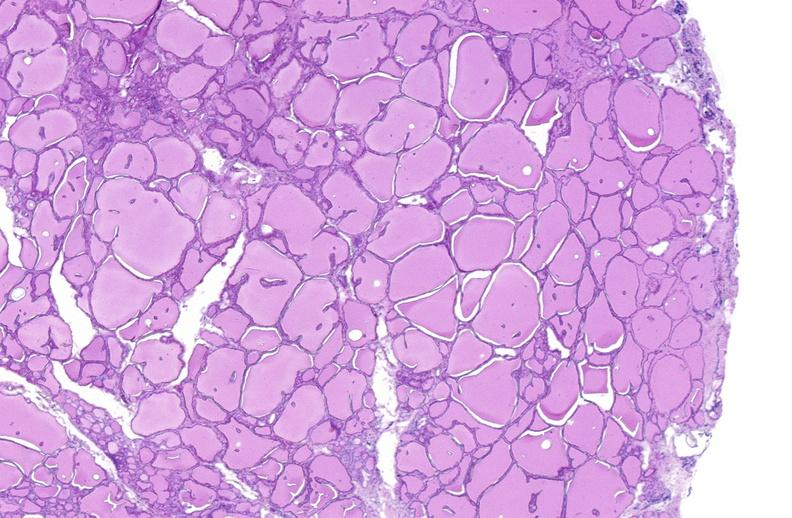does polycystic disease show thyroid gland, normal?
Answer the question using a single word or phrase. No 